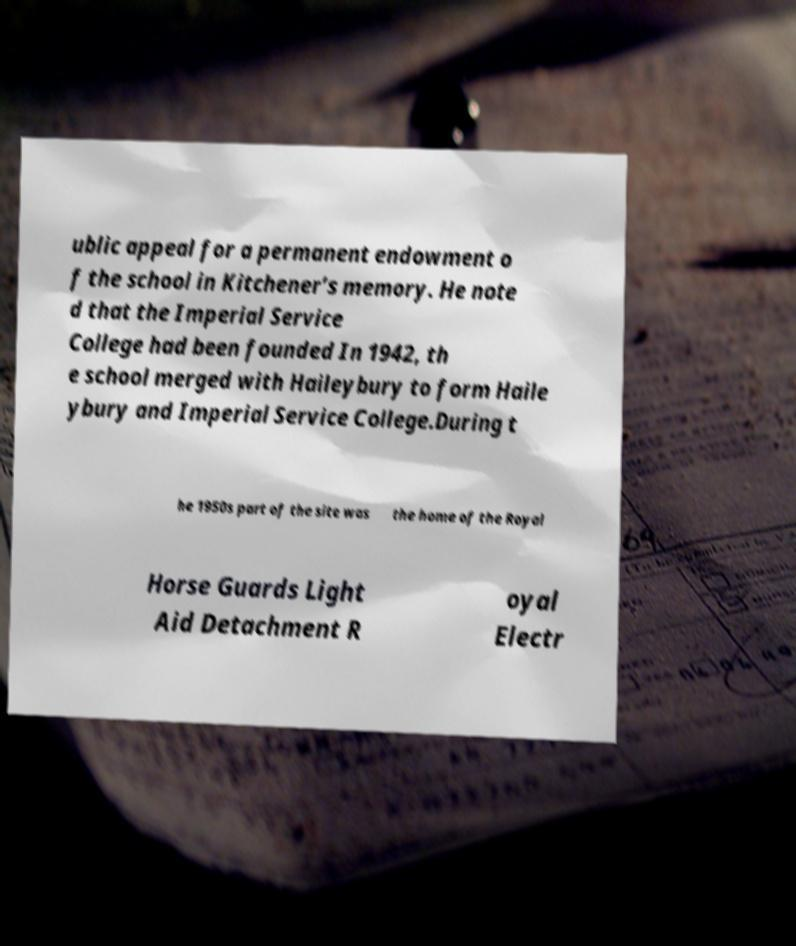Could you extract and type out the text from this image? ublic appeal for a permanent endowment o f the school in Kitchener’s memory. He note d that the Imperial Service College had been founded In 1942, th e school merged with Haileybury to form Haile ybury and Imperial Service College.During t he 1950s part of the site was the home of the Royal Horse Guards Light Aid Detachment R oyal Electr 